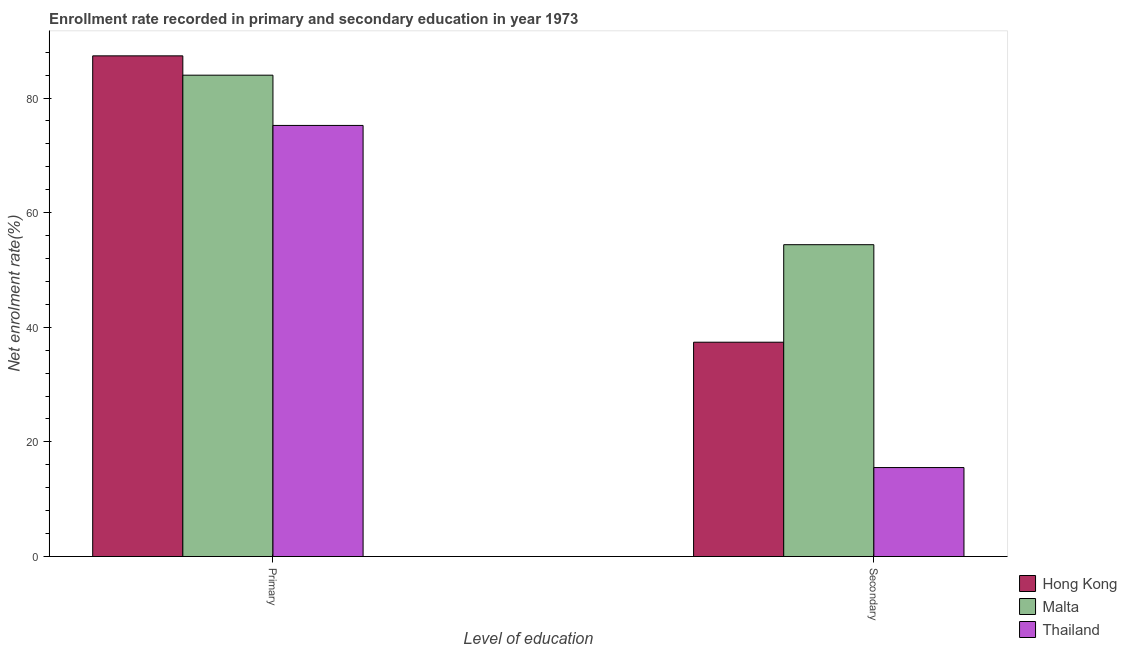Are the number of bars per tick equal to the number of legend labels?
Offer a very short reply. Yes. Are the number of bars on each tick of the X-axis equal?
Your response must be concise. Yes. What is the label of the 2nd group of bars from the left?
Your answer should be compact. Secondary. What is the enrollment rate in primary education in Hong Kong?
Your response must be concise. 87.37. Across all countries, what is the maximum enrollment rate in secondary education?
Offer a very short reply. 54.41. Across all countries, what is the minimum enrollment rate in secondary education?
Make the answer very short. 15.53. In which country was the enrollment rate in primary education maximum?
Offer a terse response. Hong Kong. In which country was the enrollment rate in primary education minimum?
Make the answer very short. Thailand. What is the total enrollment rate in primary education in the graph?
Your response must be concise. 246.59. What is the difference between the enrollment rate in primary education in Malta and that in Hong Kong?
Your answer should be compact. -3.37. What is the difference between the enrollment rate in primary education in Thailand and the enrollment rate in secondary education in Malta?
Ensure brevity in your answer.  20.81. What is the average enrollment rate in secondary education per country?
Offer a terse response. 35.78. What is the difference between the enrollment rate in primary education and enrollment rate in secondary education in Thailand?
Ensure brevity in your answer.  59.7. What is the ratio of the enrollment rate in primary education in Malta to that in Thailand?
Your answer should be compact. 1.12. In how many countries, is the enrollment rate in primary education greater than the average enrollment rate in primary education taken over all countries?
Offer a terse response. 2. What does the 2nd bar from the left in Primary represents?
Give a very brief answer. Malta. What does the 2nd bar from the right in Primary represents?
Ensure brevity in your answer.  Malta. How many bars are there?
Your answer should be compact. 6. Are all the bars in the graph horizontal?
Ensure brevity in your answer.  No. How many countries are there in the graph?
Provide a succinct answer. 3. What is the difference between two consecutive major ticks on the Y-axis?
Your answer should be very brief. 20. Does the graph contain grids?
Give a very brief answer. No. Where does the legend appear in the graph?
Provide a succinct answer. Bottom right. What is the title of the graph?
Your response must be concise. Enrollment rate recorded in primary and secondary education in year 1973. What is the label or title of the X-axis?
Provide a short and direct response. Level of education. What is the label or title of the Y-axis?
Provide a short and direct response. Net enrolment rate(%). What is the Net enrolment rate(%) of Hong Kong in Primary?
Provide a succinct answer. 87.37. What is the Net enrolment rate(%) of Malta in Primary?
Provide a succinct answer. 83.99. What is the Net enrolment rate(%) of Thailand in Primary?
Provide a succinct answer. 75.22. What is the Net enrolment rate(%) in Hong Kong in Secondary?
Offer a terse response. 37.4. What is the Net enrolment rate(%) of Malta in Secondary?
Offer a very short reply. 54.41. What is the Net enrolment rate(%) of Thailand in Secondary?
Keep it short and to the point. 15.53. Across all Level of education, what is the maximum Net enrolment rate(%) of Hong Kong?
Make the answer very short. 87.37. Across all Level of education, what is the maximum Net enrolment rate(%) in Malta?
Provide a succinct answer. 83.99. Across all Level of education, what is the maximum Net enrolment rate(%) of Thailand?
Ensure brevity in your answer.  75.22. Across all Level of education, what is the minimum Net enrolment rate(%) in Hong Kong?
Give a very brief answer. 37.4. Across all Level of education, what is the minimum Net enrolment rate(%) of Malta?
Offer a terse response. 54.41. Across all Level of education, what is the minimum Net enrolment rate(%) of Thailand?
Keep it short and to the point. 15.53. What is the total Net enrolment rate(%) in Hong Kong in the graph?
Ensure brevity in your answer.  124.76. What is the total Net enrolment rate(%) in Malta in the graph?
Provide a short and direct response. 138.41. What is the total Net enrolment rate(%) in Thailand in the graph?
Provide a succinct answer. 90.75. What is the difference between the Net enrolment rate(%) of Hong Kong in Primary and that in Secondary?
Provide a succinct answer. 49.97. What is the difference between the Net enrolment rate(%) of Malta in Primary and that in Secondary?
Offer a very short reply. 29.58. What is the difference between the Net enrolment rate(%) of Thailand in Primary and that in Secondary?
Offer a terse response. 59.7. What is the difference between the Net enrolment rate(%) of Hong Kong in Primary and the Net enrolment rate(%) of Malta in Secondary?
Your response must be concise. 32.95. What is the difference between the Net enrolment rate(%) in Hong Kong in Primary and the Net enrolment rate(%) in Thailand in Secondary?
Make the answer very short. 71.84. What is the difference between the Net enrolment rate(%) of Malta in Primary and the Net enrolment rate(%) of Thailand in Secondary?
Provide a succinct answer. 68.47. What is the average Net enrolment rate(%) of Hong Kong per Level of education?
Your answer should be very brief. 62.38. What is the average Net enrolment rate(%) of Malta per Level of education?
Ensure brevity in your answer.  69.2. What is the average Net enrolment rate(%) in Thailand per Level of education?
Ensure brevity in your answer.  45.38. What is the difference between the Net enrolment rate(%) of Hong Kong and Net enrolment rate(%) of Malta in Primary?
Make the answer very short. 3.37. What is the difference between the Net enrolment rate(%) of Hong Kong and Net enrolment rate(%) of Thailand in Primary?
Provide a short and direct response. 12.14. What is the difference between the Net enrolment rate(%) in Malta and Net enrolment rate(%) in Thailand in Primary?
Give a very brief answer. 8.77. What is the difference between the Net enrolment rate(%) of Hong Kong and Net enrolment rate(%) of Malta in Secondary?
Make the answer very short. -17.02. What is the difference between the Net enrolment rate(%) in Hong Kong and Net enrolment rate(%) in Thailand in Secondary?
Offer a very short reply. 21.87. What is the difference between the Net enrolment rate(%) of Malta and Net enrolment rate(%) of Thailand in Secondary?
Your answer should be very brief. 38.89. What is the ratio of the Net enrolment rate(%) of Hong Kong in Primary to that in Secondary?
Your answer should be very brief. 2.34. What is the ratio of the Net enrolment rate(%) in Malta in Primary to that in Secondary?
Make the answer very short. 1.54. What is the ratio of the Net enrolment rate(%) of Thailand in Primary to that in Secondary?
Give a very brief answer. 4.85. What is the difference between the highest and the second highest Net enrolment rate(%) in Hong Kong?
Make the answer very short. 49.97. What is the difference between the highest and the second highest Net enrolment rate(%) of Malta?
Make the answer very short. 29.58. What is the difference between the highest and the second highest Net enrolment rate(%) of Thailand?
Your answer should be very brief. 59.7. What is the difference between the highest and the lowest Net enrolment rate(%) in Hong Kong?
Your answer should be very brief. 49.97. What is the difference between the highest and the lowest Net enrolment rate(%) in Malta?
Provide a succinct answer. 29.58. What is the difference between the highest and the lowest Net enrolment rate(%) of Thailand?
Your response must be concise. 59.7. 